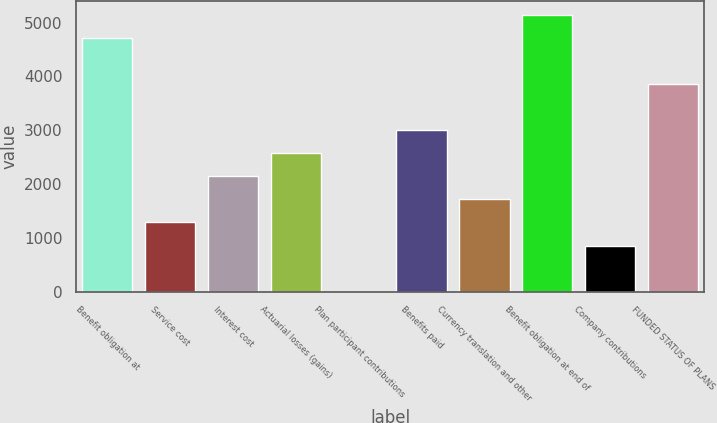<chart> <loc_0><loc_0><loc_500><loc_500><bar_chart><fcel>Benefit obligation at<fcel>Service cost<fcel>Interest cost<fcel>Actuarial losses (gains)<fcel>Plan participant contributions<fcel>Benefits paid<fcel>Currency translation and other<fcel>Benefit obligation at end of<fcel>Company contributions<fcel>FUNDED STATUS OF PLANS<nl><fcel>4709.93<fcel>1288.09<fcel>2143.55<fcel>2571.28<fcel>4.9<fcel>2999.01<fcel>1715.82<fcel>5137.66<fcel>860.36<fcel>3854.47<nl></chart> 